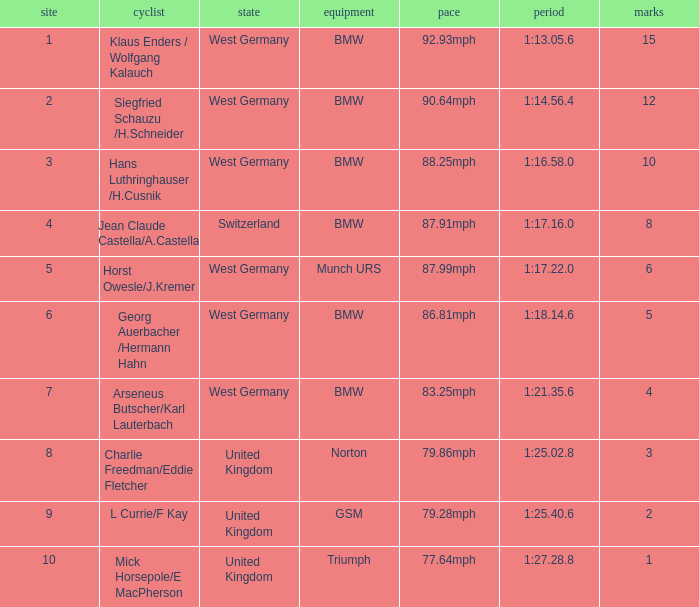Which places have points larger than 10? None. 